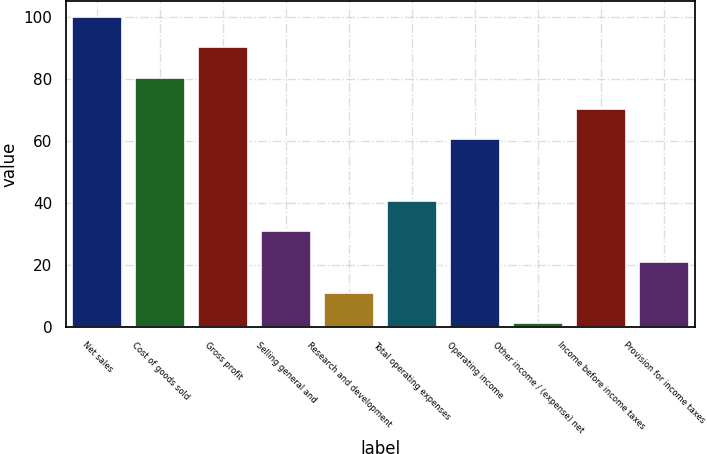Convert chart. <chart><loc_0><loc_0><loc_500><loc_500><bar_chart><fcel>Net sales<fcel>Cost of goods sold<fcel>Gross profit<fcel>Selling general and<fcel>Research and development<fcel>Total operating expenses<fcel>Operating income<fcel>Other income / (expense) net<fcel>Income before income taxes<fcel>Provision for income taxes<nl><fcel>100<fcel>80.24<fcel>90.12<fcel>30.84<fcel>11.08<fcel>40.72<fcel>60.48<fcel>1.2<fcel>70.36<fcel>20.96<nl></chart> 